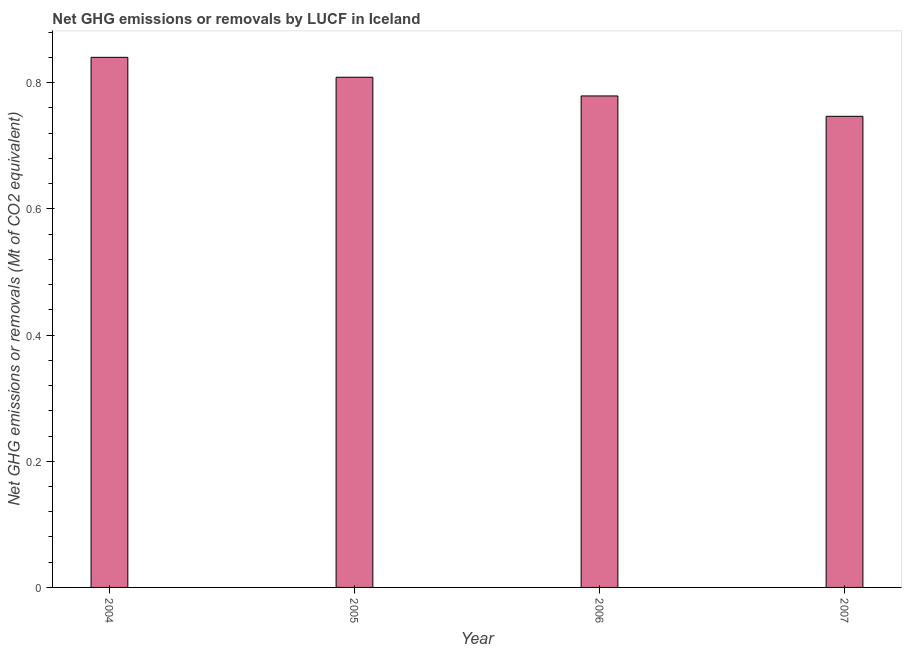Does the graph contain any zero values?
Give a very brief answer. No. What is the title of the graph?
Provide a short and direct response. Net GHG emissions or removals by LUCF in Iceland. What is the label or title of the X-axis?
Offer a very short reply. Year. What is the label or title of the Y-axis?
Keep it short and to the point. Net GHG emissions or removals (Mt of CO2 equivalent). What is the ghg net emissions or removals in 2005?
Give a very brief answer. 0.81. Across all years, what is the maximum ghg net emissions or removals?
Offer a terse response. 0.84. Across all years, what is the minimum ghg net emissions or removals?
Your response must be concise. 0.75. In which year was the ghg net emissions or removals maximum?
Offer a terse response. 2004. In which year was the ghg net emissions or removals minimum?
Ensure brevity in your answer.  2007. What is the sum of the ghg net emissions or removals?
Offer a very short reply. 3.17. What is the difference between the ghg net emissions or removals in 2004 and 2006?
Your answer should be very brief. 0.06. What is the average ghg net emissions or removals per year?
Your answer should be compact. 0.79. What is the median ghg net emissions or removals?
Your answer should be very brief. 0.79. Do a majority of the years between 2006 and 2005 (inclusive) have ghg net emissions or removals greater than 0.2 Mt?
Offer a terse response. No. What is the ratio of the ghg net emissions or removals in 2004 to that in 2005?
Ensure brevity in your answer.  1.04. What is the difference between the highest and the second highest ghg net emissions or removals?
Keep it short and to the point. 0.03. Is the sum of the ghg net emissions or removals in 2004 and 2006 greater than the maximum ghg net emissions or removals across all years?
Your answer should be compact. Yes. What is the difference between the highest and the lowest ghg net emissions or removals?
Ensure brevity in your answer.  0.09. How many years are there in the graph?
Provide a short and direct response. 4. What is the difference between two consecutive major ticks on the Y-axis?
Ensure brevity in your answer.  0.2. Are the values on the major ticks of Y-axis written in scientific E-notation?
Provide a short and direct response. No. What is the Net GHG emissions or removals (Mt of CO2 equivalent) in 2004?
Offer a very short reply. 0.84. What is the Net GHG emissions or removals (Mt of CO2 equivalent) in 2005?
Your answer should be compact. 0.81. What is the Net GHG emissions or removals (Mt of CO2 equivalent) of 2006?
Make the answer very short. 0.78. What is the Net GHG emissions or removals (Mt of CO2 equivalent) of 2007?
Provide a succinct answer. 0.75. What is the difference between the Net GHG emissions or removals (Mt of CO2 equivalent) in 2004 and 2005?
Offer a very short reply. 0.03. What is the difference between the Net GHG emissions or removals (Mt of CO2 equivalent) in 2004 and 2006?
Offer a terse response. 0.06. What is the difference between the Net GHG emissions or removals (Mt of CO2 equivalent) in 2004 and 2007?
Provide a succinct answer. 0.09. What is the difference between the Net GHG emissions or removals (Mt of CO2 equivalent) in 2005 and 2006?
Your response must be concise. 0.03. What is the difference between the Net GHG emissions or removals (Mt of CO2 equivalent) in 2005 and 2007?
Make the answer very short. 0.06. What is the difference between the Net GHG emissions or removals (Mt of CO2 equivalent) in 2006 and 2007?
Provide a succinct answer. 0.03. What is the ratio of the Net GHG emissions or removals (Mt of CO2 equivalent) in 2004 to that in 2005?
Make the answer very short. 1.04. What is the ratio of the Net GHG emissions or removals (Mt of CO2 equivalent) in 2004 to that in 2006?
Make the answer very short. 1.08. What is the ratio of the Net GHG emissions or removals (Mt of CO2 equivalent) in 2004 to that in 2007?
Offer a very short reply. 1.12. What is the ratio of the Net GHG emissions or removals (Mt of CO2 equivalent) in 2005 to that in 2006?
Offer a very short reply. 1.04. What is the ratio of the Net GHG emissions or removals (Mt of CO2 equivalent) in 2005 to that in 2007?
Your answer should be compact. 1.08. What is the ratio of the Net GHG emissions or removals (Mt of CO2 equivalent) in 2006 to that in 2007?
Offer a very short reply. 1.04. 